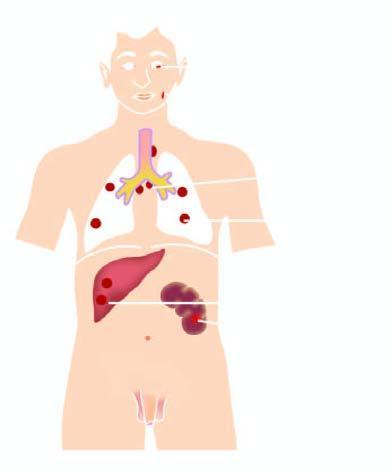what are predominantly seen in lymph nodes and throughout lung parenchyma?
Answer the question using a single word or phrase. The lesions 